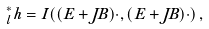<formula> <loc_0><loc_0><loc_500><loc_500>\Phi _ { l } ^ { * } h = I ( ( E + J B ) \cdot , ( E + J B ) \cdot ) \, ,</formula> 